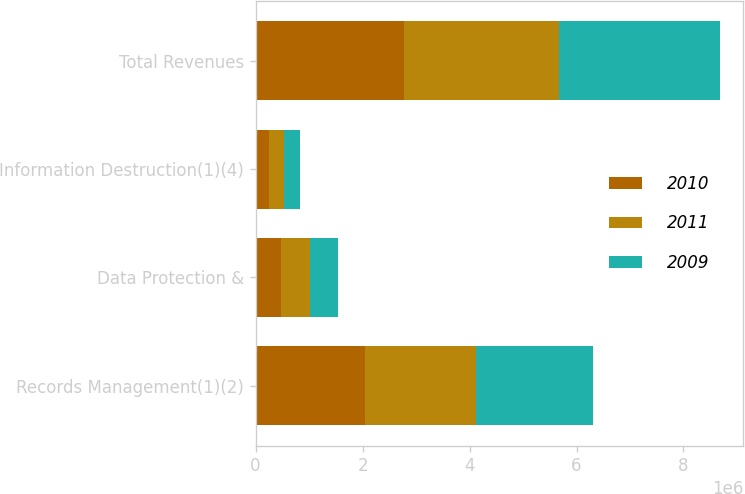Convert chart. <chart><loc_0><loc_0><loc_500><loc_500><stacked_bar_chart><ecel><fcel>Records Management(1)(2)<fcel>Data Protection &<fcel>Information Destruction(1)(4)<fcel>Total Revenues<nl><fcel>2010<fcel>2.0405e+06<fcel>483909<fcel>249978<fcel>2.77438e+06<nl><fcel>2011<fcel>2.08149e+06<fcel>531580<fcel>279277<fcel>2.89235e+06<nl><fcel>2009<fcel>2.18315e+06<fcel>522632<fcel>308917<fcel>3.0147e+06<nl></chart> 